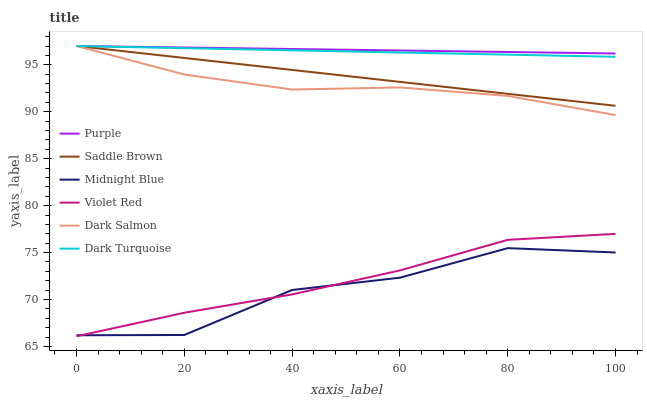Does Midnight Blue have the minimum area under the curve?
Answer yes or no. Yes. Does Purple have the maximum area under the curve?
Answer yes or no. Yes. Does Purple have the minimum area under the curve?
Answer yes or no. No. Does Midnight Blue have the maximum area under the curve?
Answer yes or no. No. Is Saddle Brown the smoothest?
Answer yes or no. Yes. Is Midnight Blue the roughest?
Answer yes or no. Yes. Is Purple the smoothest?
Answer yes or no. No. Is Purple the roughest?
Answer yes or no. No. Does Midnight Blue have the lowest value?
Answer yes or no. No. Does Saddle Brown have the highest value?
Answer yes or no. Yes. Does Midnight Blue have the highest value?
Answer yes or no. No. Is Violet Red less than Dark Turquoise?
Answer yes or no. Yes. Is Saddle Brown greater than Midnight Blue?
Answer yes or no. Yes. Does Midnight Blue intersect Violet Red?
Answer yes or no. Yes. Is Midnight Blue less than Violet Red?
Answer yes or no. No. Is Midnight Blue greater than Violet Red?
Answer yes or no. No. Does Violet Red intersect Dark Turquoise?
Answer yes or no. No. 